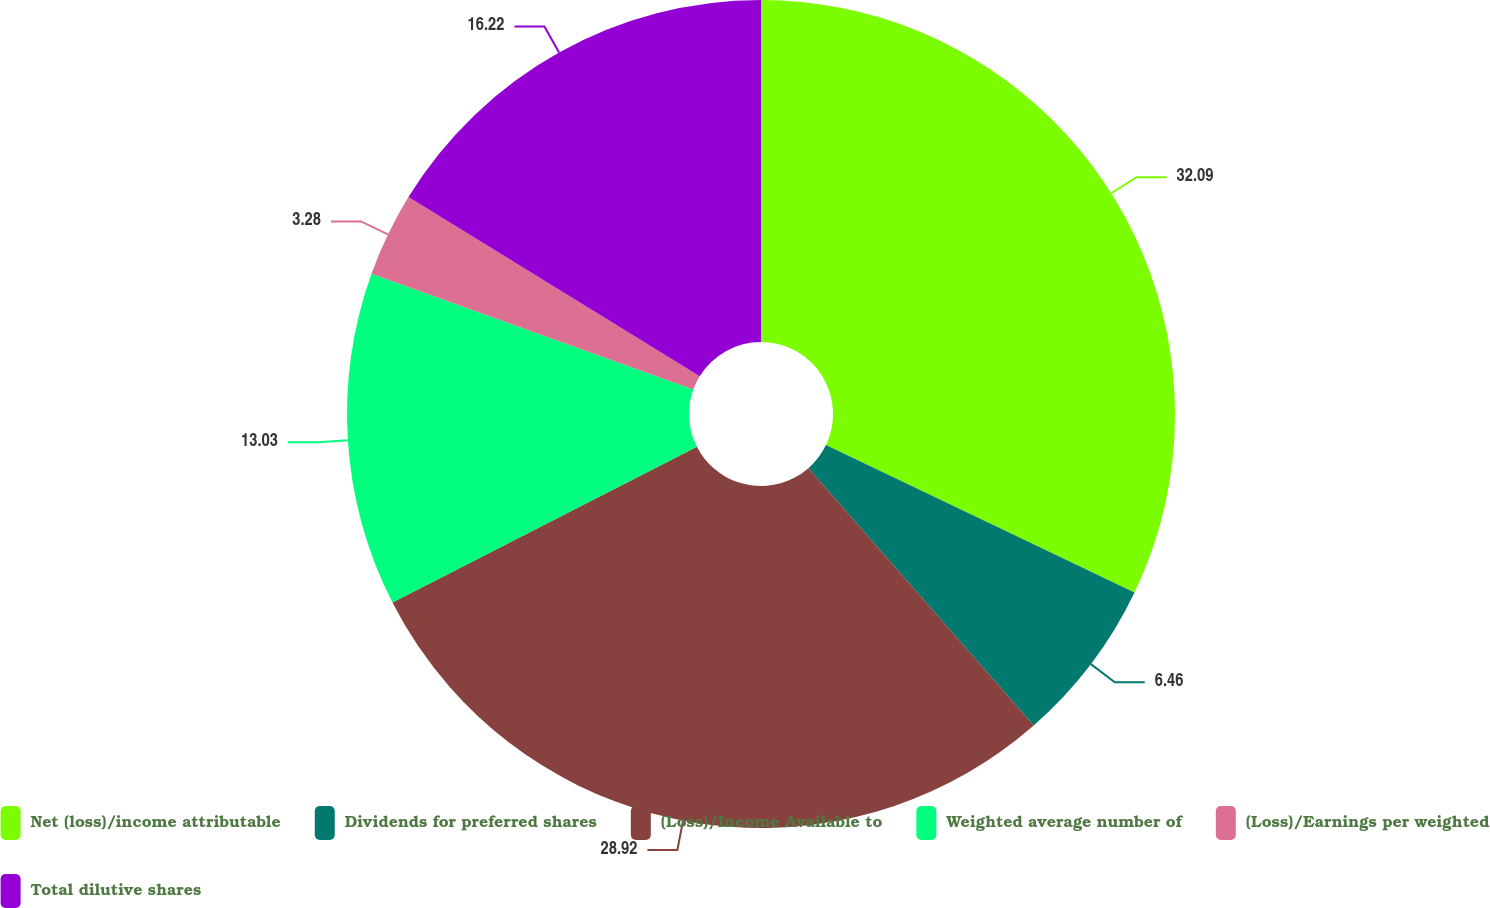<chart> <loc_0><loc_0><loc_500><loc_500><pie_chart><fcel>Net (loss)/income attributable<fcel>Dividends for preferred shares<fcel>(Loss)/Income Available to<fcel>Weighted average number of<fcel>(Loss)/Earnings per weighted<fcel>Total dilutive shares<nl><fcel>32.1%<fcel>6.46%<fcel>28.92%<fcel>13.03%<fcel>3.28%<fcel>16.22%<nl></chart> 